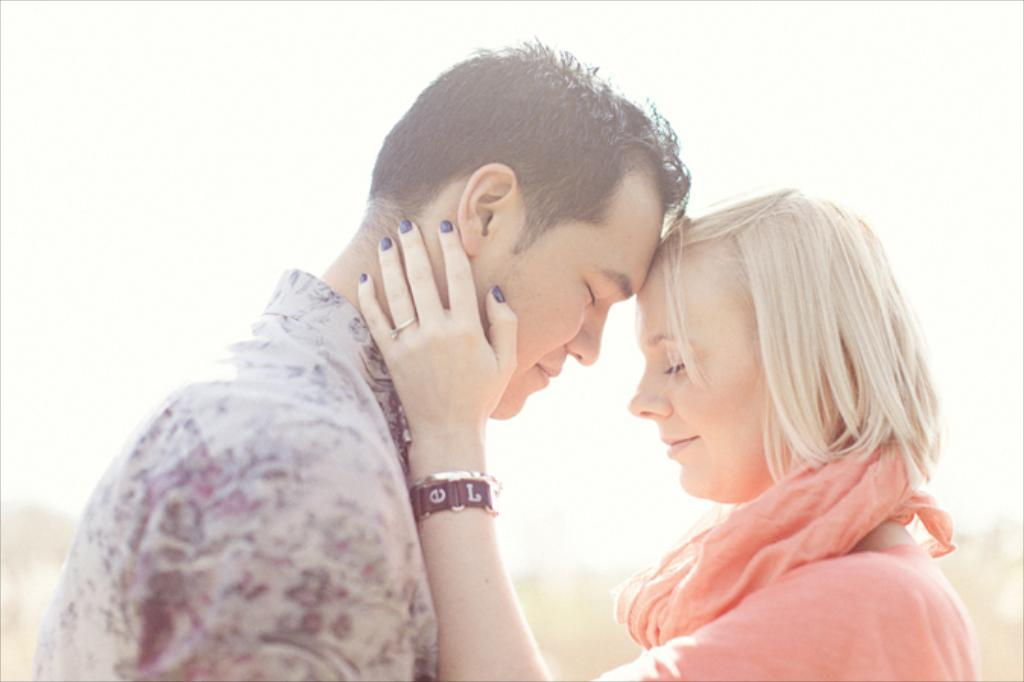What is the gender of the two people in the image? There is a man and a woman in the image. What is the woman wearing in the image? The woman is wearing a pink dress. What is the woman doing with the man in the image? The woman is holding the man's face. What can be seen in the background of the image? There is sky visible in the background of the image. How many monkeys can be seen holding the man's face in the image? There are no monkeys present in the image; it features a man and a woman. What type of grip does the woman have on the man's face in the image? The image does not provide enough detail to describe the type of grip the woman has on the man's face. 